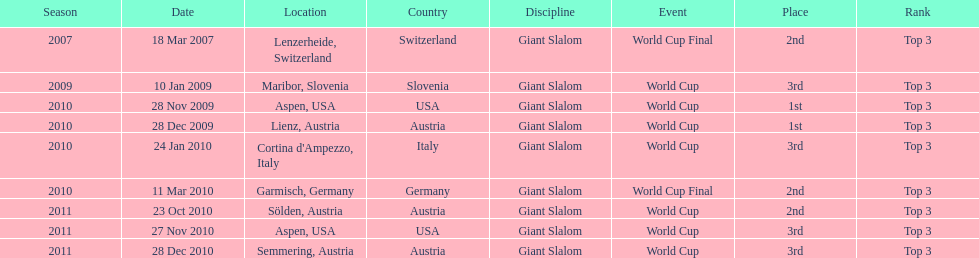Where was her first win? Aspen, USA. 